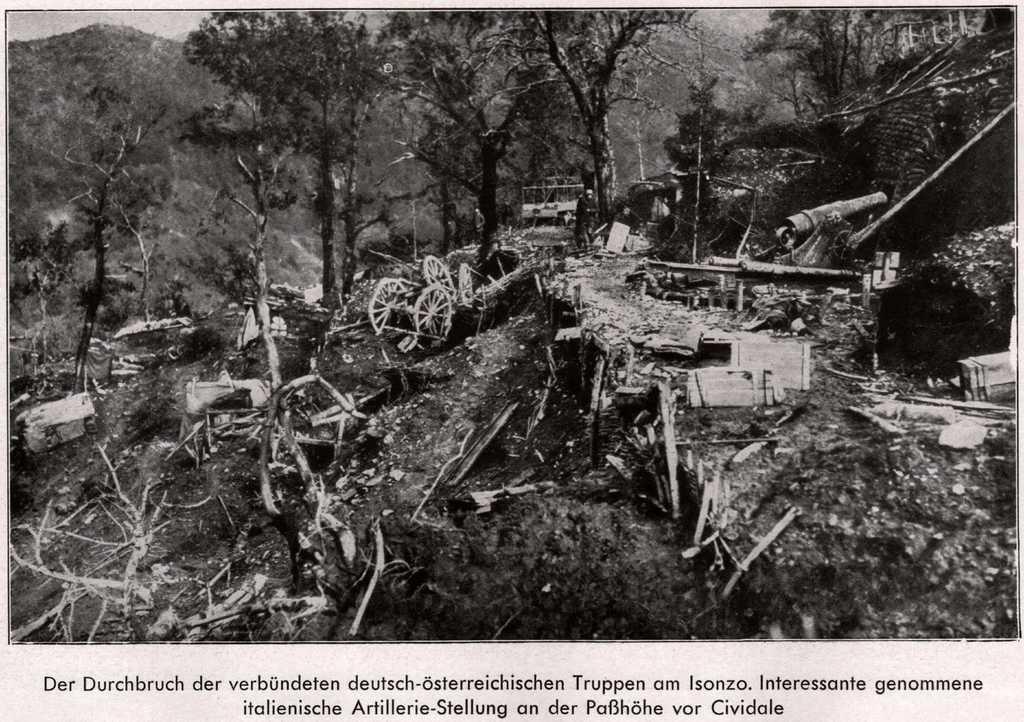Describe this image in one or two sentences. This is a black and white image. In this image I can see many wooden objects, vehicle, many trees and the sky. 